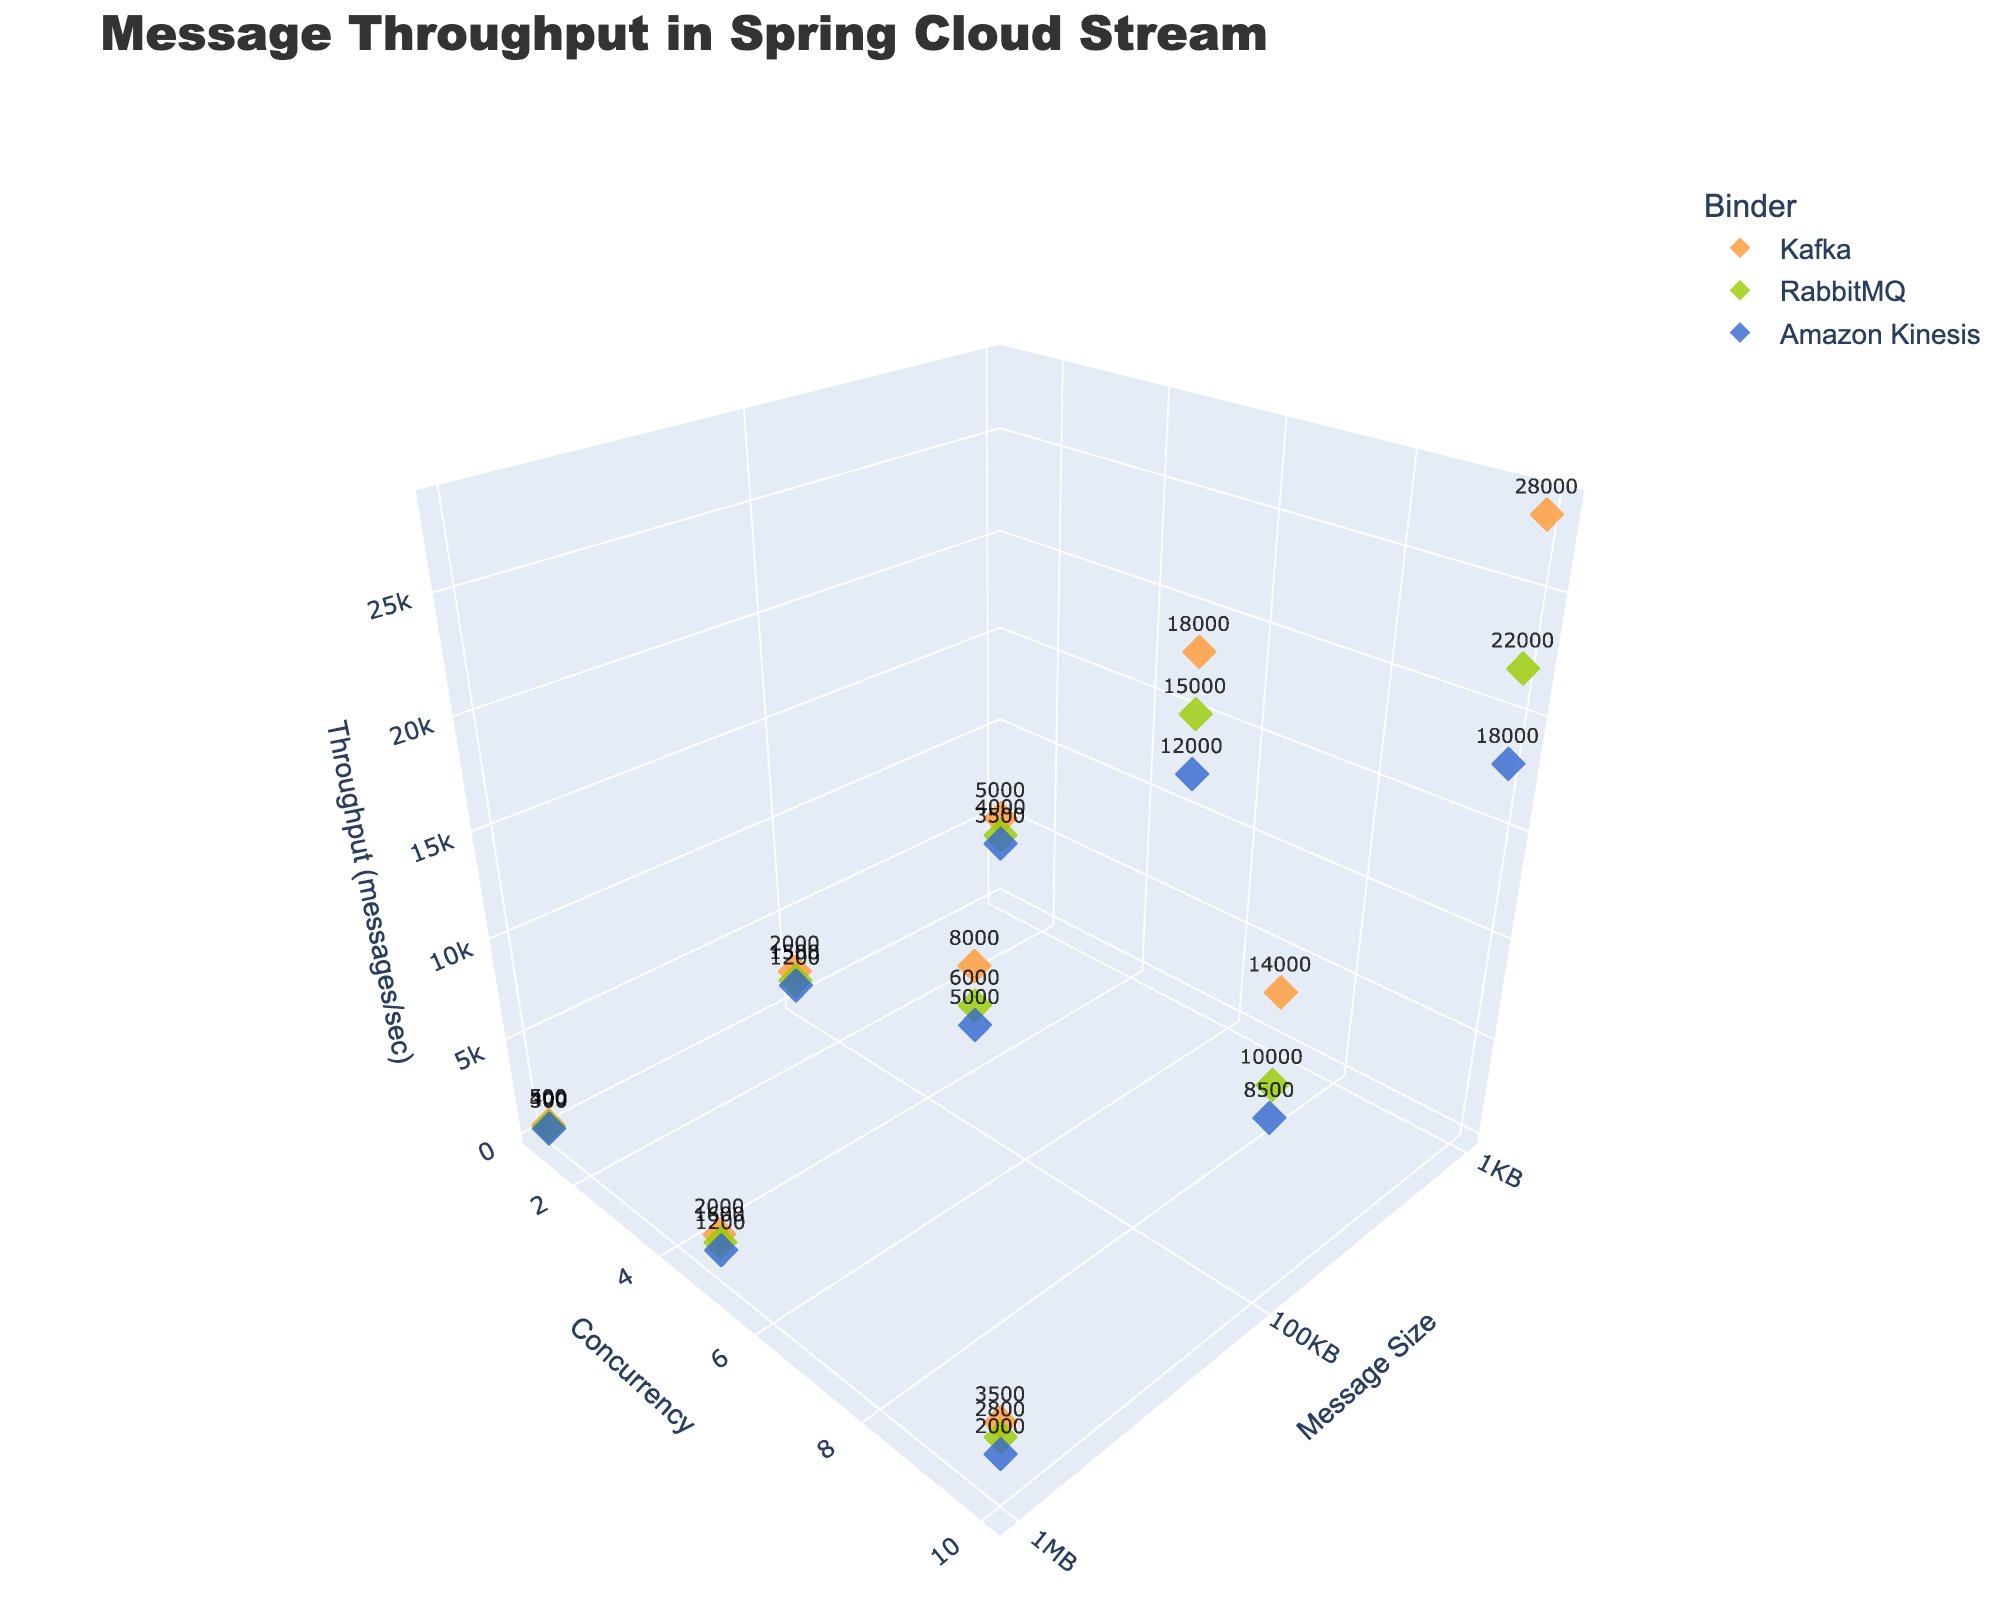How many binders are represented in the plot? By examining the legend, we can see that different color markers are used to represent each binder. The legend lists Kafka, RabbitMQ, and Amazon Kinesis.
Answer: 3 What is the title of the plot? The title is located at the top of the plot. Reading it directly gives us the title.
Answer: Message Throughput in Spring Cloud Stream Which binder shows the highest throughput at a concurrency level of 10 and message size of 1KB? Look at the 3D points with x=1KB and y=10, then identify the highest z-value, which corresponds to throughput. The binder name can be found either through the marker color in the legend or text next to the marker.
Answer: Kafka What is the total throughput for Kafka when the concurrency level is 5? Sum the throughput values for Kafka at concurrency level 5 across all message sizes. These values are 18000 (1KB), 8000 (100KB), and 2000 (1MB). The total is 18000 + 8000 + 2000.
Answer: 28000 Between RabbitMQ and Amazon Kinesis, which binder generally has lower throughput for 100KB messages at all concurrency levels? Compare the z-values (throughput) for RabbitMQ and Amazon Kinesis at message size 100KB for each concurrency level (1, 5, 10). RabbitMQ has throughputs of 1500, 6000, 10000. Amazon Kinesis has throughputs of 1200, 5000, 8500.
Answer: Amazon Kinesis What is the difference in throughput between Kafka and RabbitMQ for 1MB messages at a concurrency level of 1? Identify the respective throughput values from the plot (500 for Kafka and 400 for RabbitMQ), and calculate the difference.
Answer: 100 Considering all binders, which message size (1KB, 100KB, or 1MB) appears to generally yield the lowest throughput? By observing the z-axis values grouped by message size, we note that 1MB messages consistently have lower throughputs compared to 1KB and 100KB messages.
Answer: 1MB What concurrency level is associated with the highest overall throughput in the entire plot? Look at the z-axis values and identify the highest point. This point has a concurrency level of 10 with Kafka binder and 1KB message size.
Answer: 10 Among all bench markers, what is the maximum throughput in the plot, and which binder does it belong to? The maximum z-value is the highest throughput value seen across all binders and parameters. The maximum is 28000, belonging to Kafka.
Answer: 28000 (Kafka) Which binder has the least variance in throughput for 1KB messages across all concurrency levels? Analyze the spread of z-values (throughput) for 1KB messages in each binder. The binder with the smallest range between its minimum and maximum z-values will have the least variance. RabbitMQ's throughputs are 4000, 15000, 22000, while Kafka's are 5000, 18000, 28000, and Amazon Kinesis's are 3500, 12000, 18000.
Answer: Amazon Kinesis 